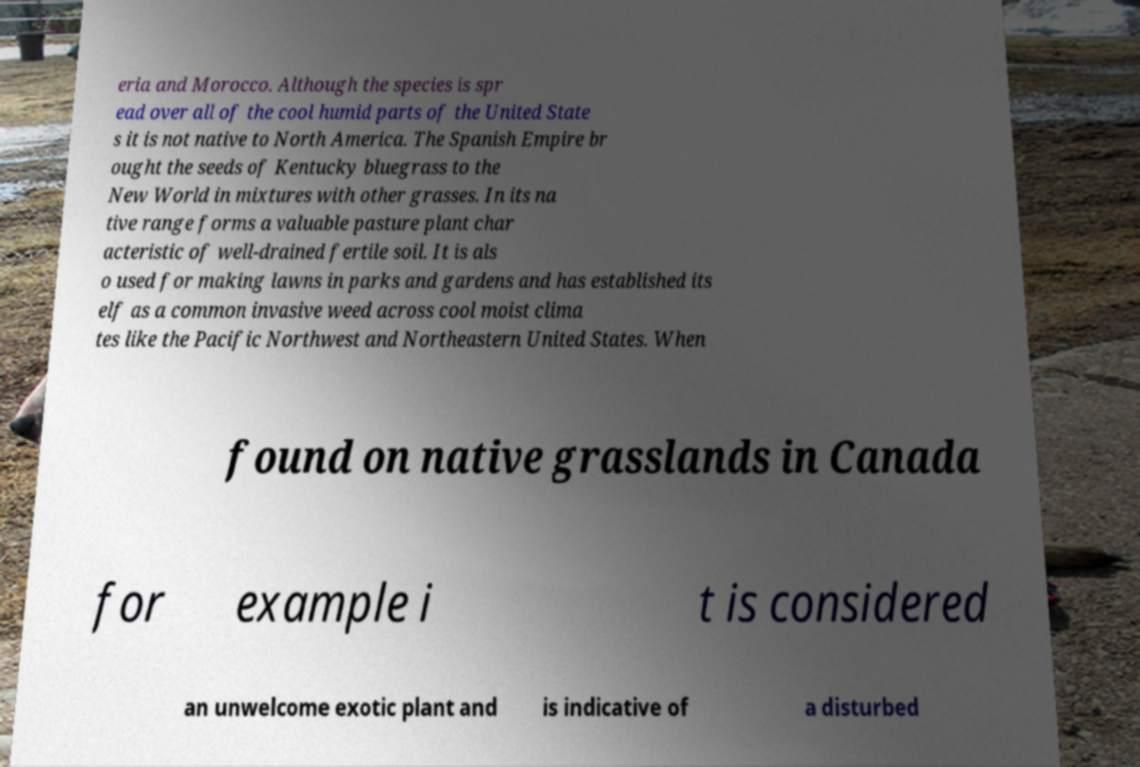I need the written content from this picture converted into text. Can you do that? eria and Morocco. Although the species is spr ead over all of the cool humid parts of the United State s it is not native to North America. The Spanish Empire br ought the seeds of Kentucky bluegrass to the New World in mixtures with other grasses. In its na tive range forms a valuable pasture plant char acteristic of well-drained fertile soil. It is als o used for making lawns in parks and gardens and has established its elf as a common invasive weed across cool moist clima tes like the Pacific Northwest and Northeastern United States. When found on native grasslands in Canada for example i t is considered an unwelcome exotic plant and is indicative of a disturbed 